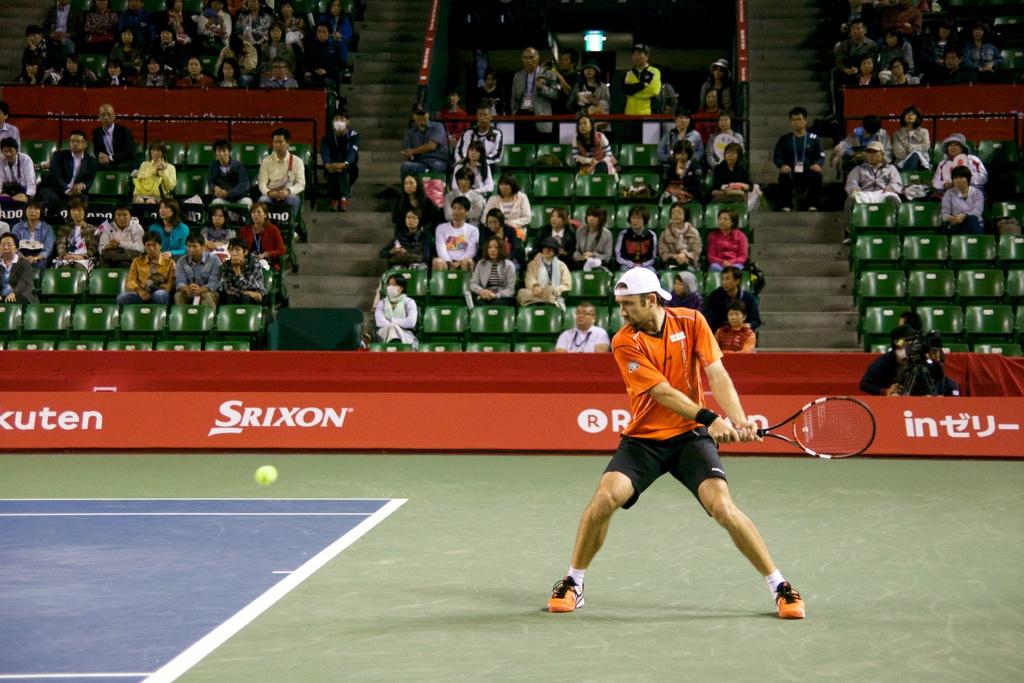Who is the sponsor second from the left?
Your response must be concise. Srixon. What is the last sponsor name?
Provide a succinct answer. Intu. 